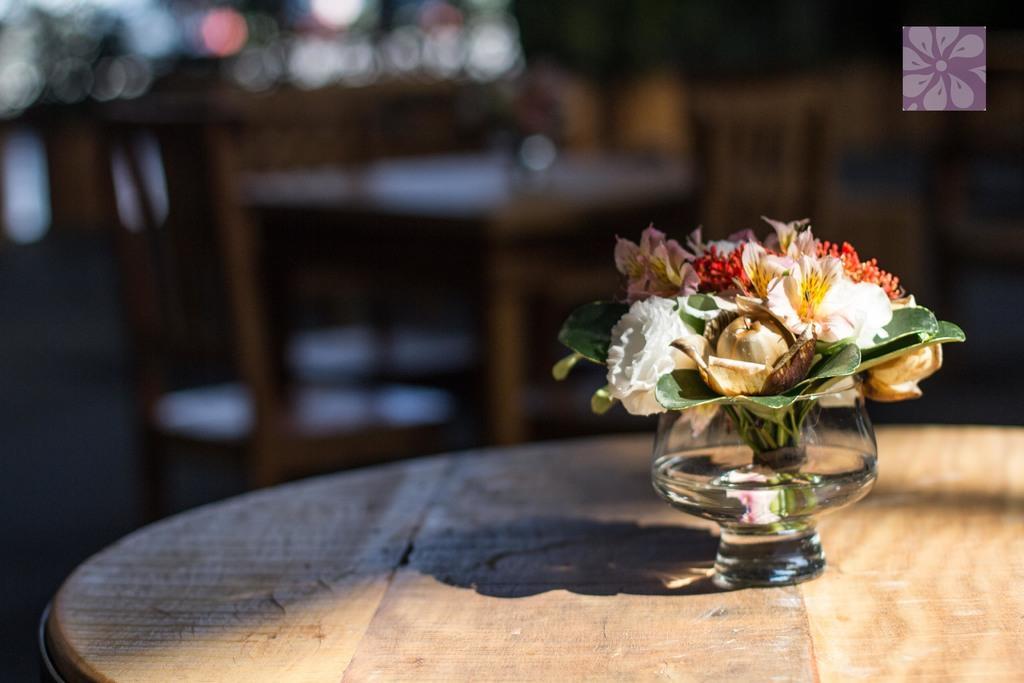Could you give a brief overview of what you see in this image? In the image we can see there is a table on which there is a flowers which are kept in the glass and at the back picture is blur. 